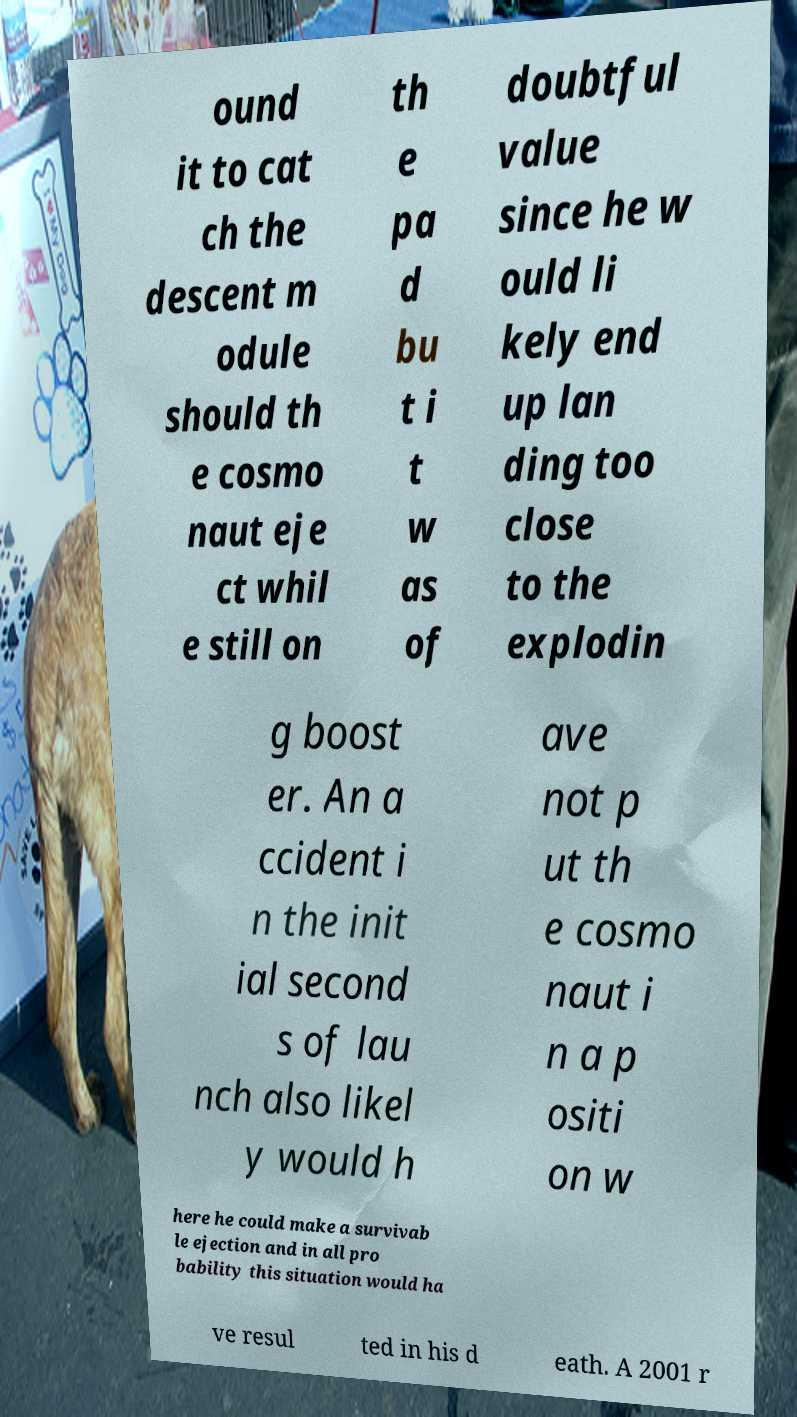For documentation purposes, I need the text within this image transcribed. Could you provide that? ound it to cat ch the descent m odule should th e cosmo naut eje ct whil e still on th e pa d bu t i t w as of doubtful value since he w ould li kely end up lan ding too close to the explodin g boost er. An a ccident i n the init ial second s of lau nch also likel y would h ave not p ut th e cosmo naut i n a p ositi on w here he could make a survivab le ejection and in all pro bability this situation would ha ve resul ted in his d eath. A 2001 r 